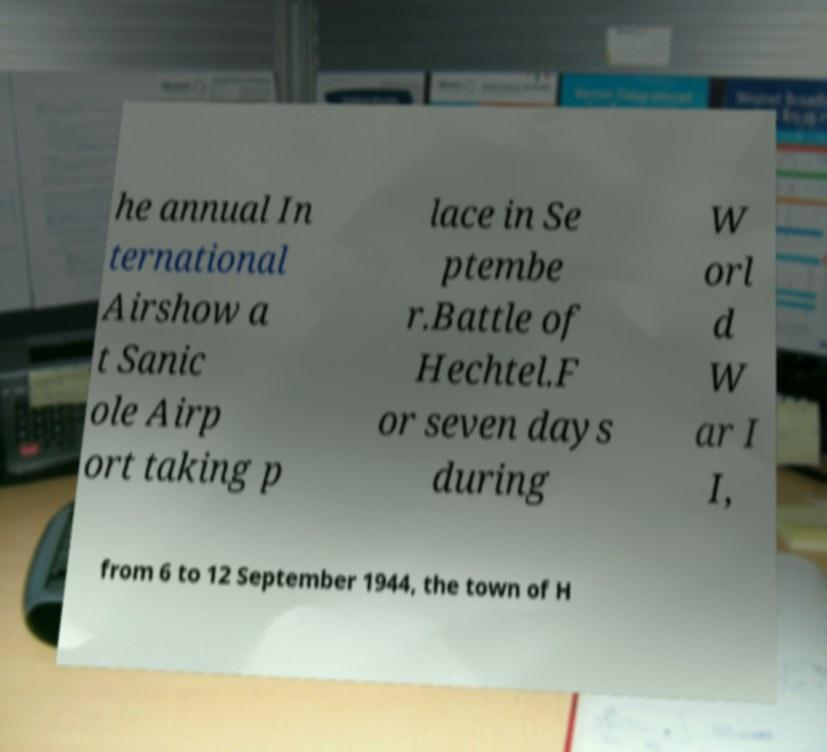Please read and relay the text visible in this image. What does it say? he annual In ternational Airshow a t Sanic ole Airp ort taking p lace in Se ptembe r.Battle of Hechtel.F or seven days during W orl d W ar I I, from 6 to 12 September 1944, the town of H 